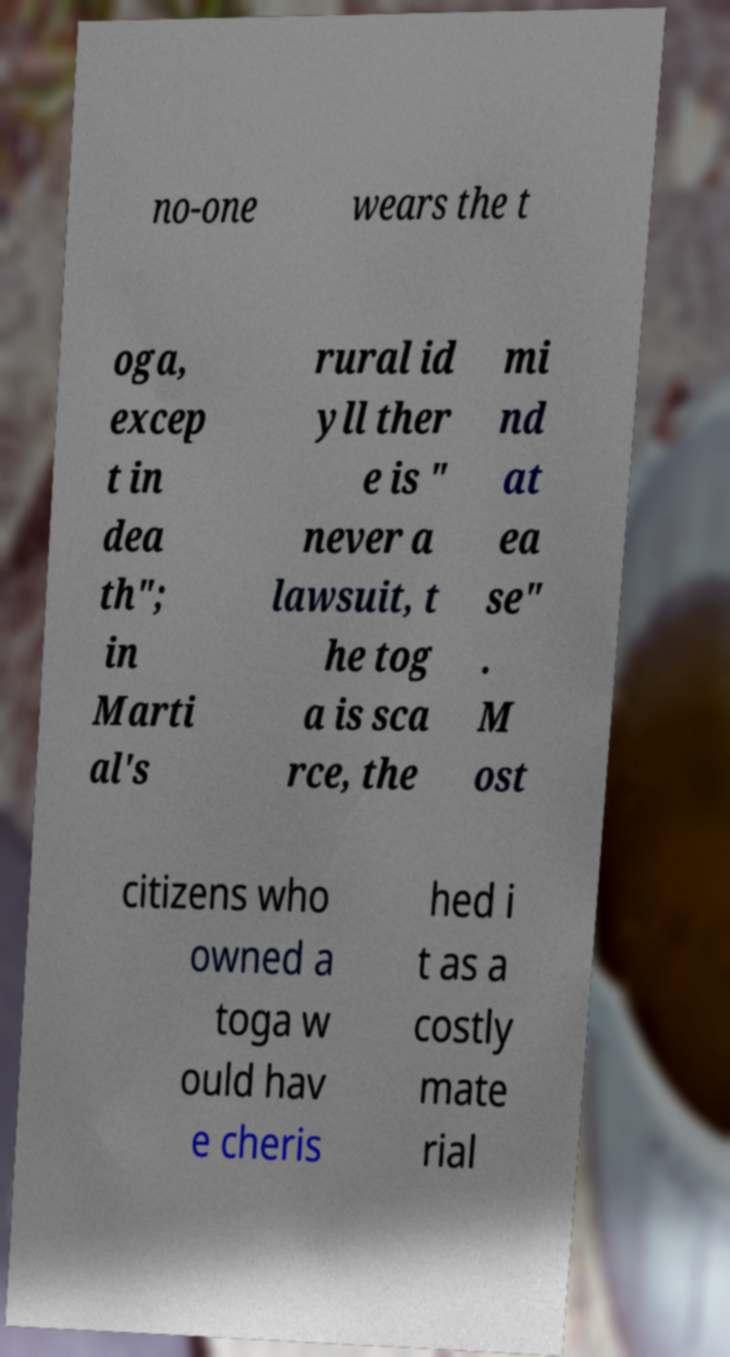For documentation purposes, I need the text within this image transcribed. Could you provide that? no-one wears the t oga, excep t in dea th"; in Marti al's rural id yll ther e is " never a lawsuit, t he tog a is sca rce, the mi nd at ea se" . M ost citizens who owned a toga w ould hav e cheris hed i t as a costly mate rial 